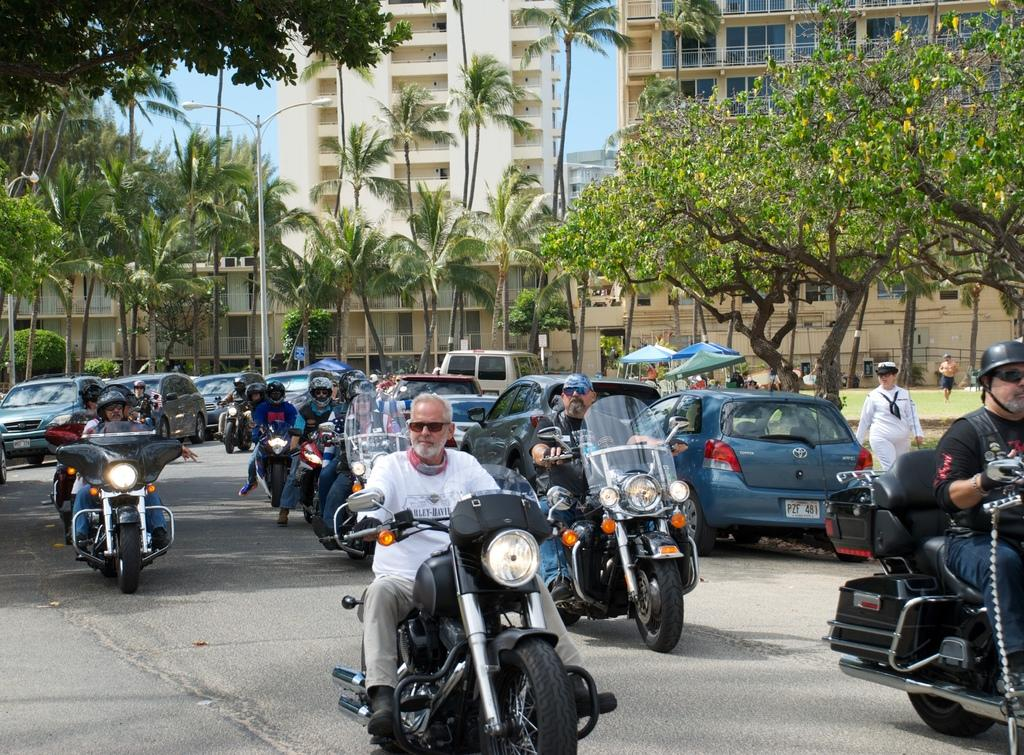What activity are the people in the image engaged in? The group of people are riding a bike in the image. What can be seen in the background of the image? There is a car, a tent, a tree, a building, a street light, and the sky visible in the background of the image. What type of boat can be seen floating in the river in the image? There is no river or boat present in the image. 